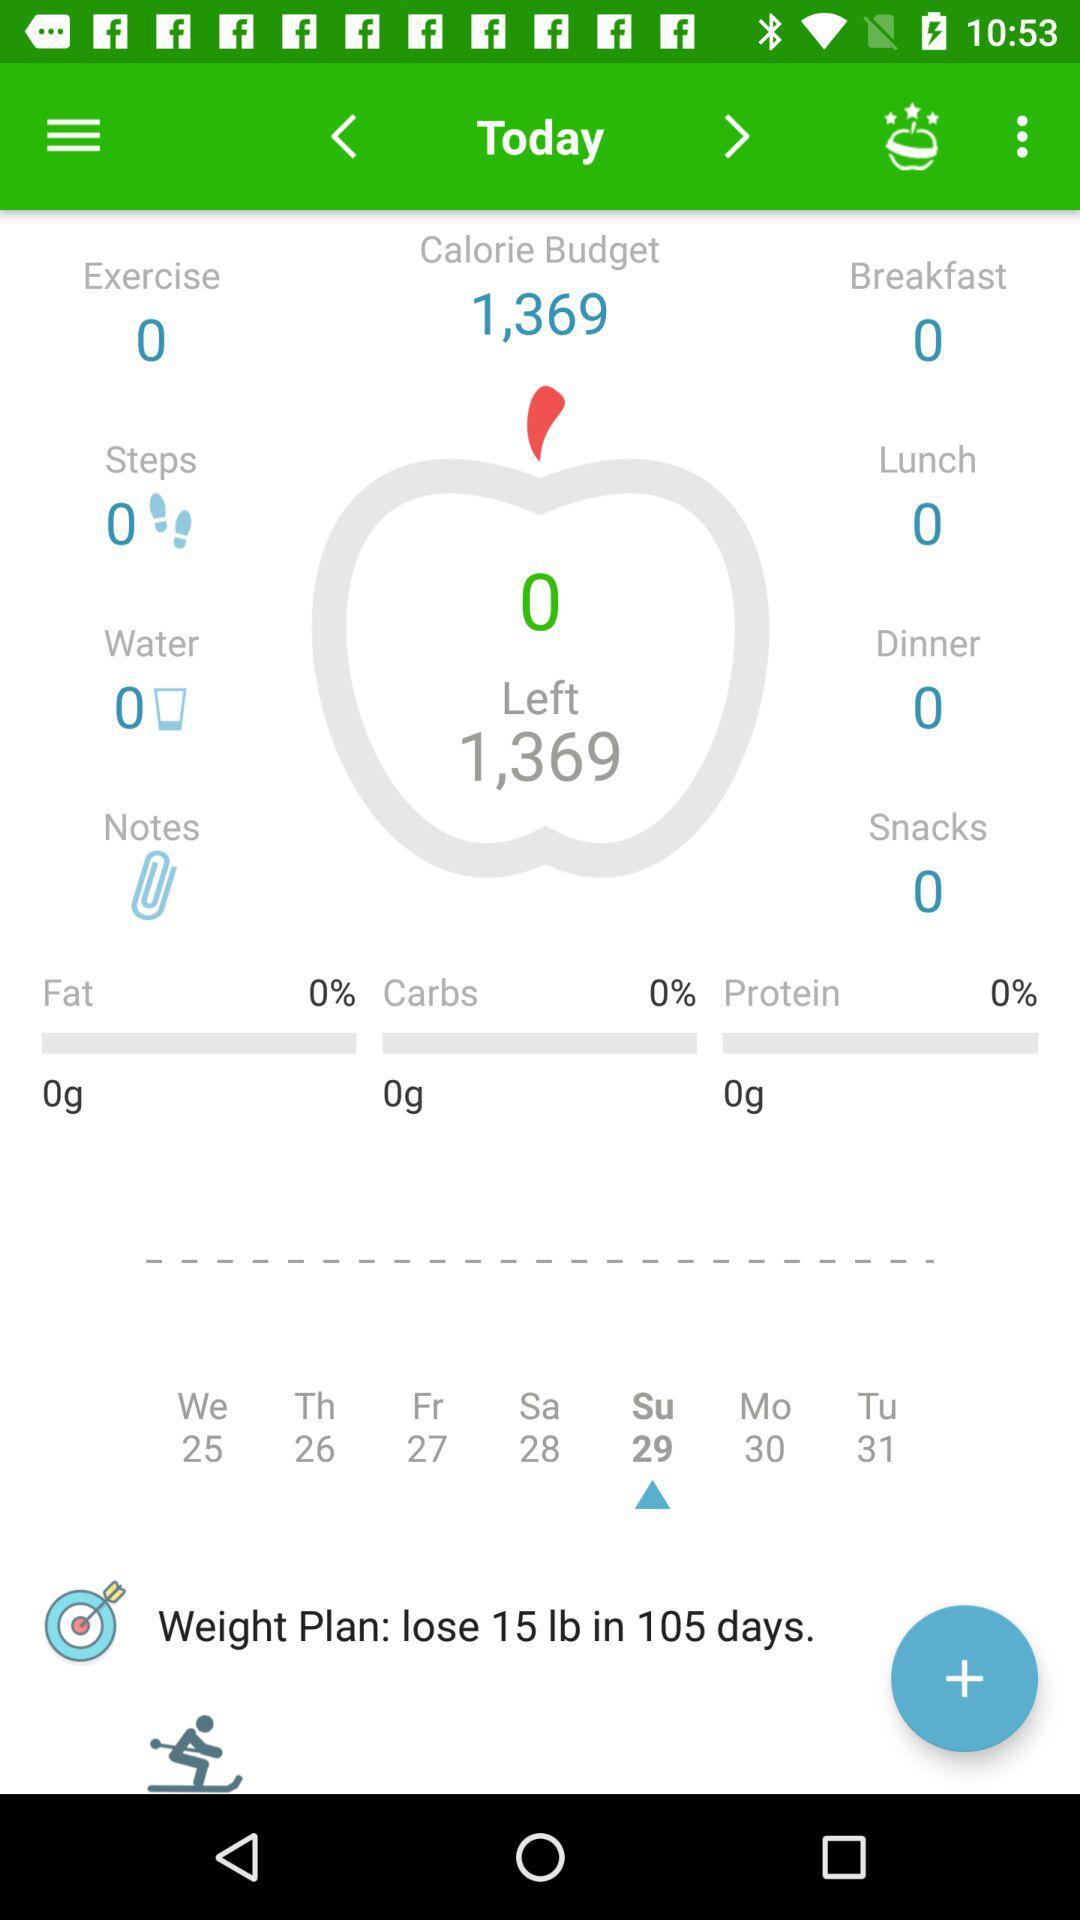How many calories are left? There are 1,369 calories left. 